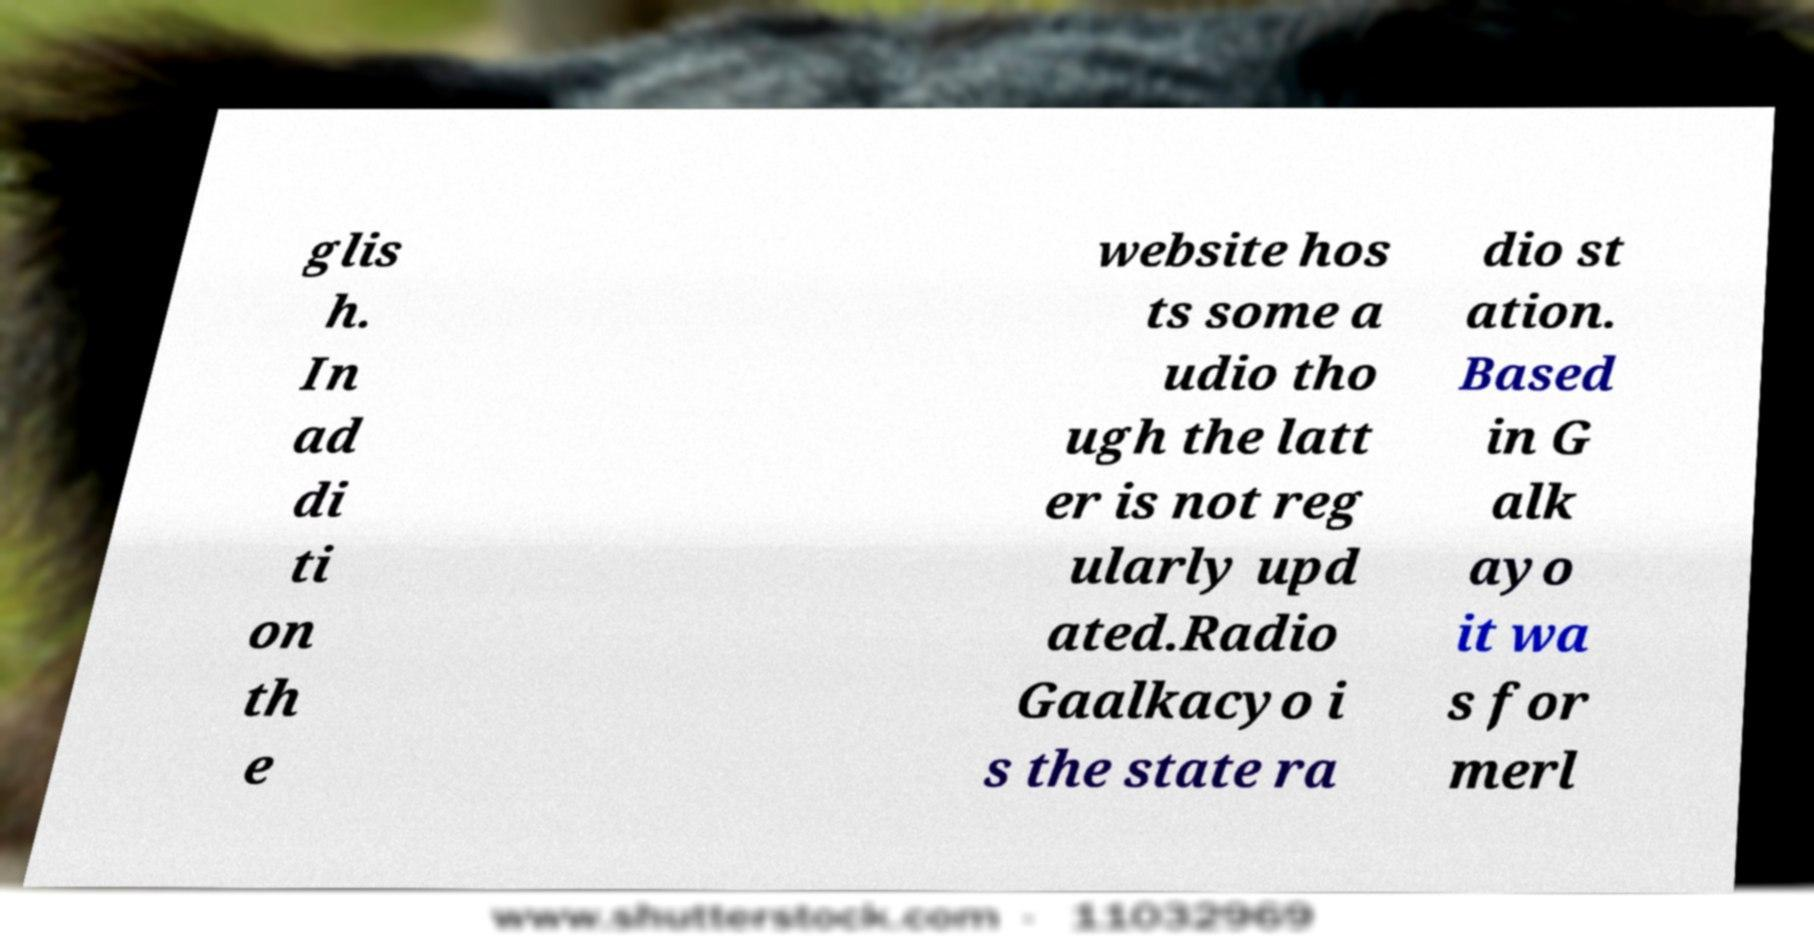Please read and relay the text visible in this image. What does it say? glis h. In ad di ti on th e website hos ts some a udio tho ugh the latt er is not reg ularly upd ated.Radio Gaalkacyo i s the state ra dio st ation. Based in G alk ayo it wa s for merl 